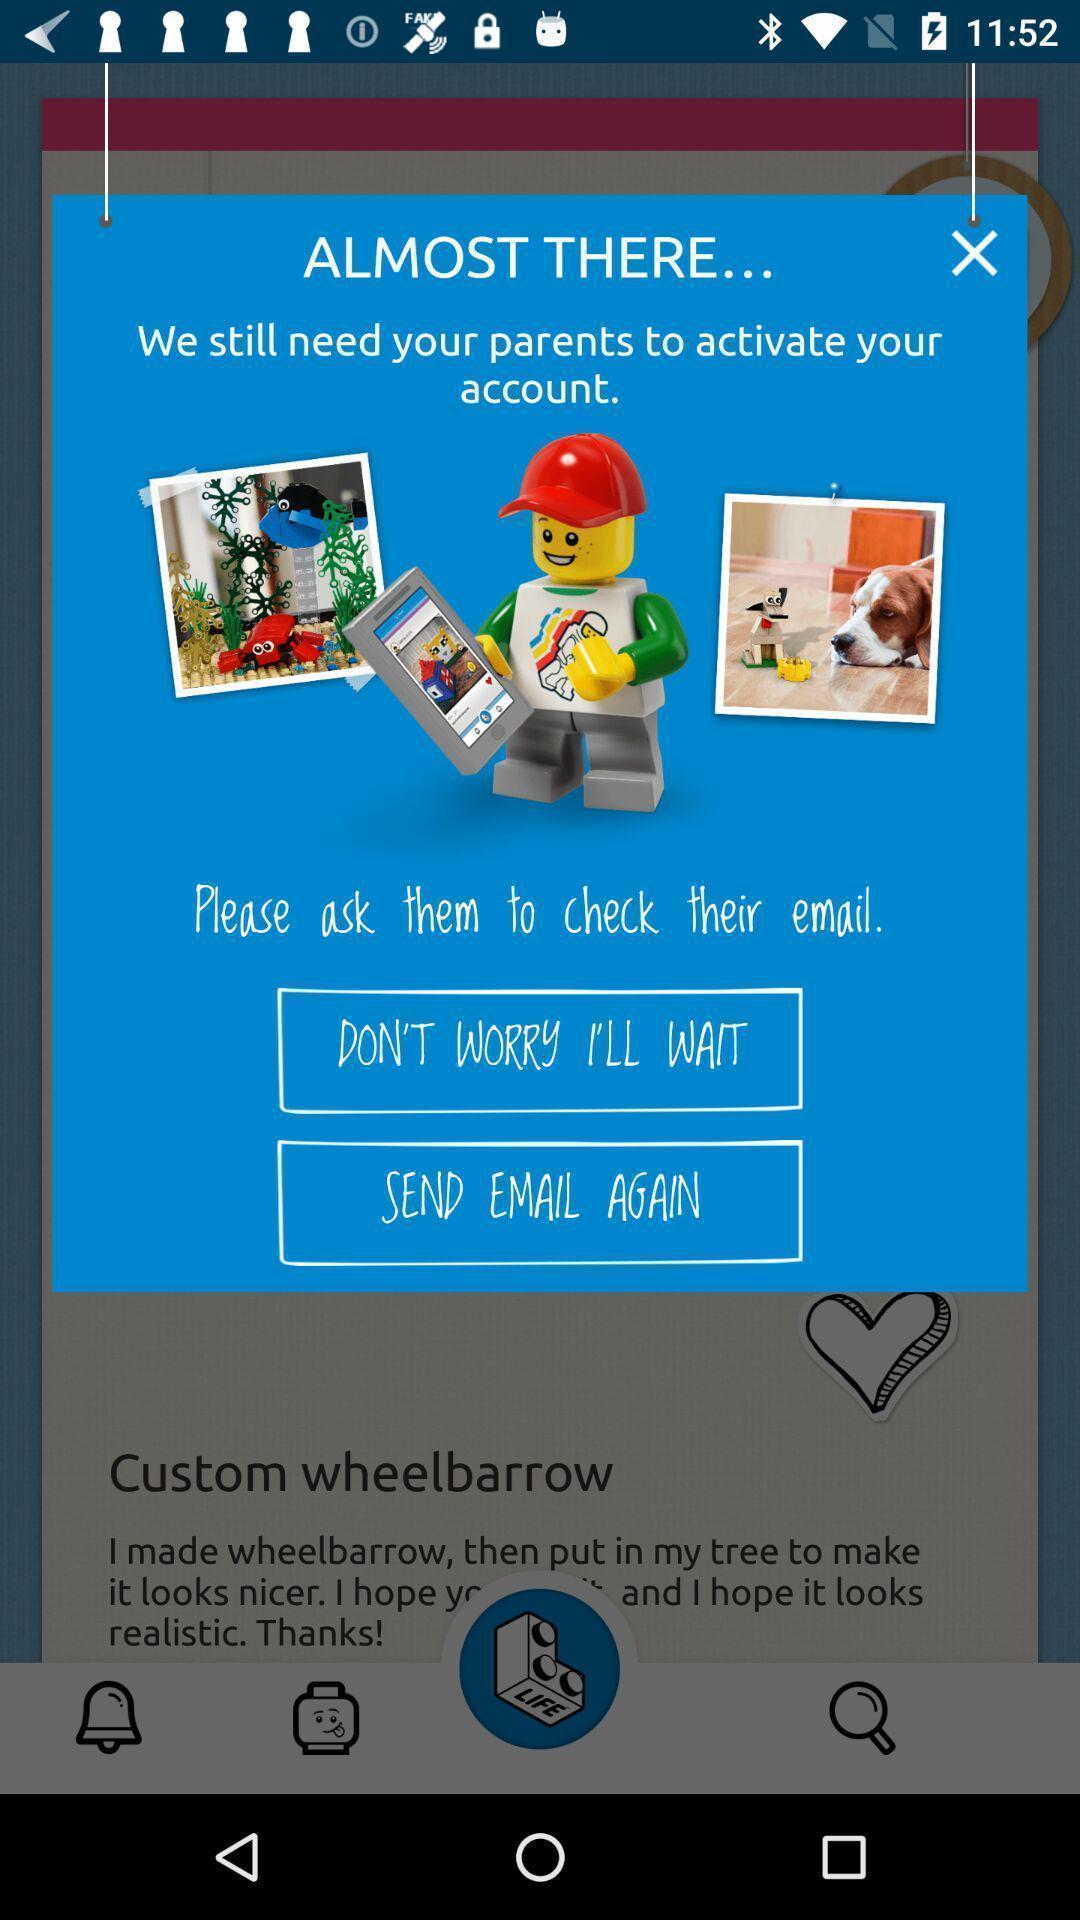Tell me what you see in this picture. Pop-up shows activation options. 